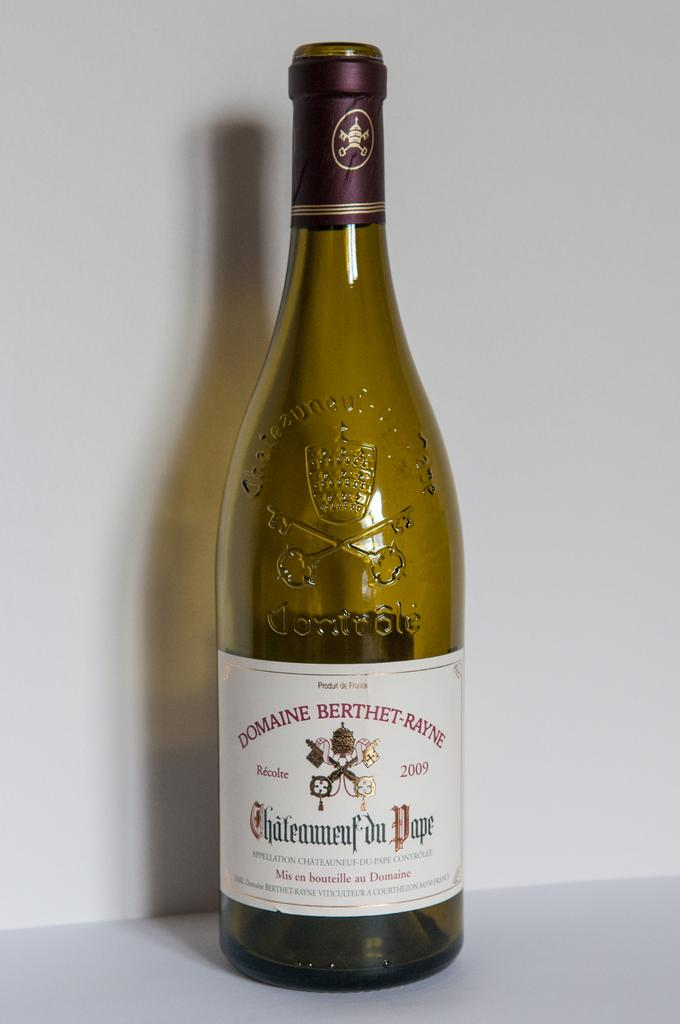<image>
Provide a brief description of the given image. A bottle of Domaine Berthet-Rayne sits on a table. 